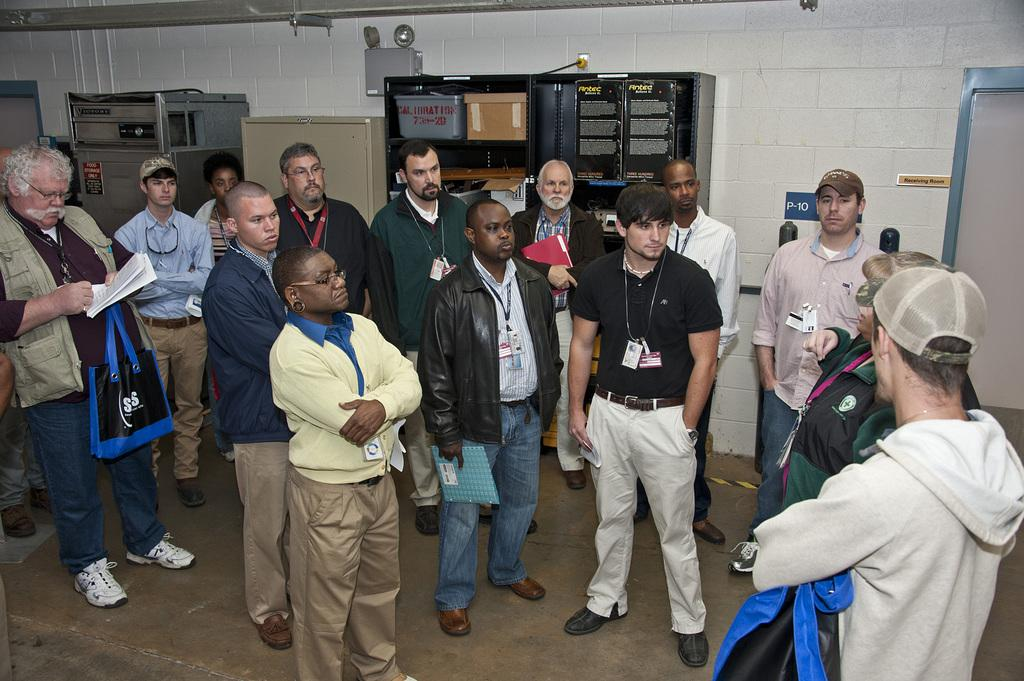What can be seen in the image? There are people standing in the image. What is present in the background of the image? There is a black color rack in the background of the image. What is the color of the wall visible in the image? There is a white color wall in the image. What type of sink can be seen in the image? There is no sink present in the image. What smell is associated with the people in the image? The image does not provide any information about the smell associated with the people. 